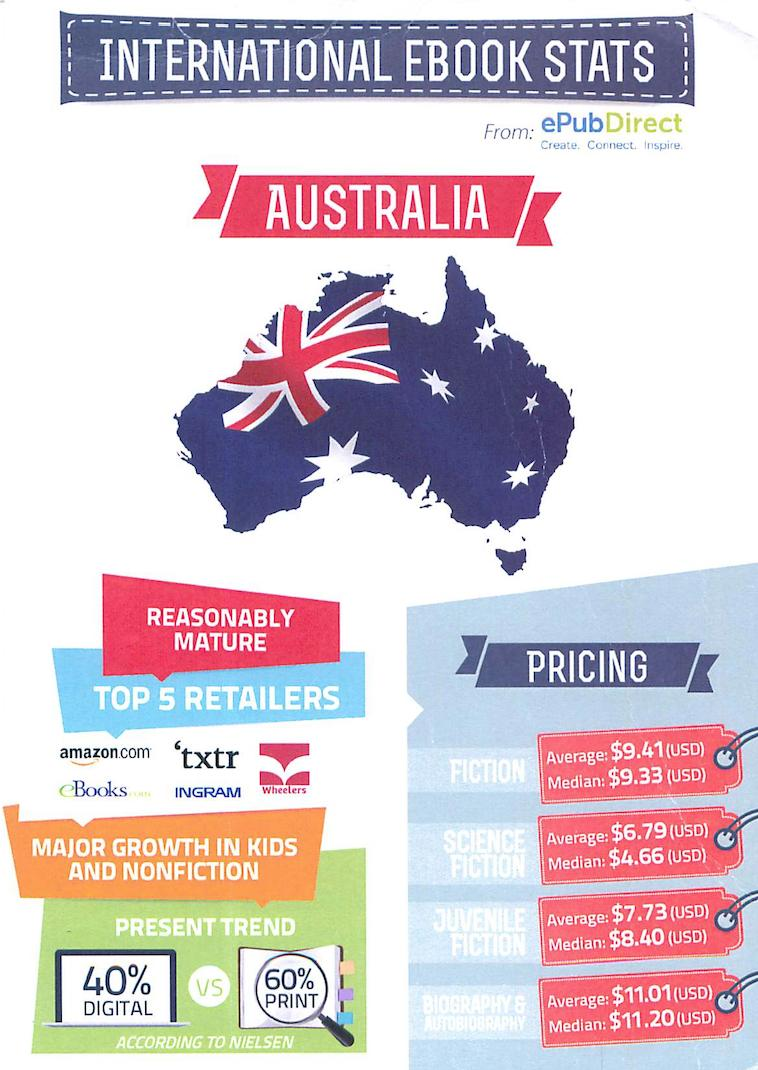Give some essential details in this illustration. Wheelers are retailers. Science fiction has the lowest pricing among all genres. The difference in percentage between digital and print advertising is 20%. The average price difference between juvenile fiction and science fiction is 0.94. 